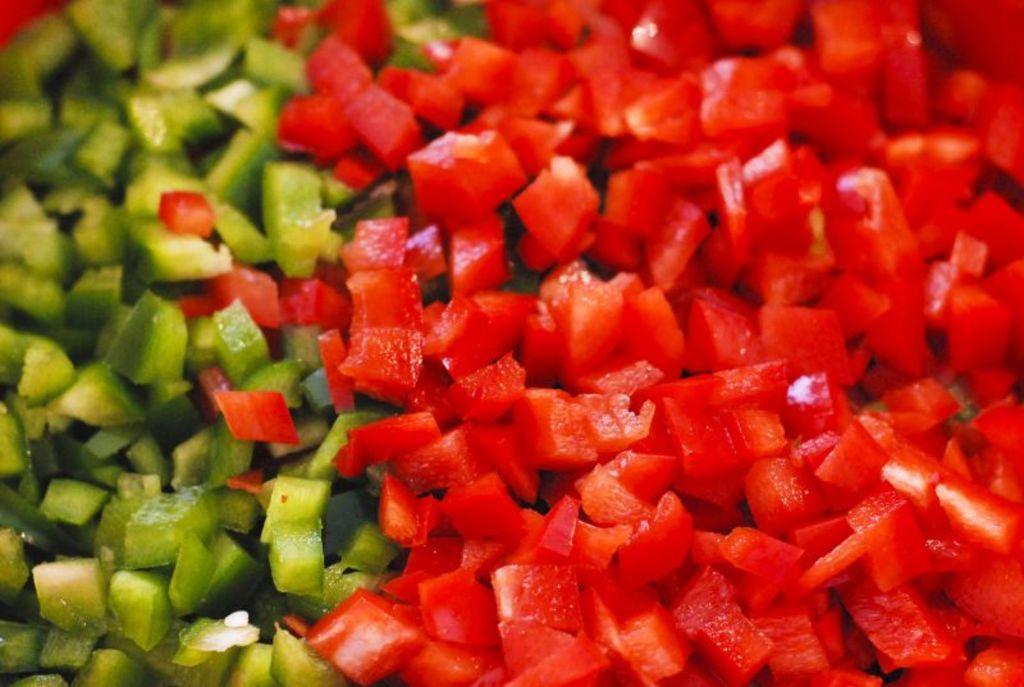Could you give a brief overview of what you see in this image? In this image, I can see the chopped red and green bell peppers. 